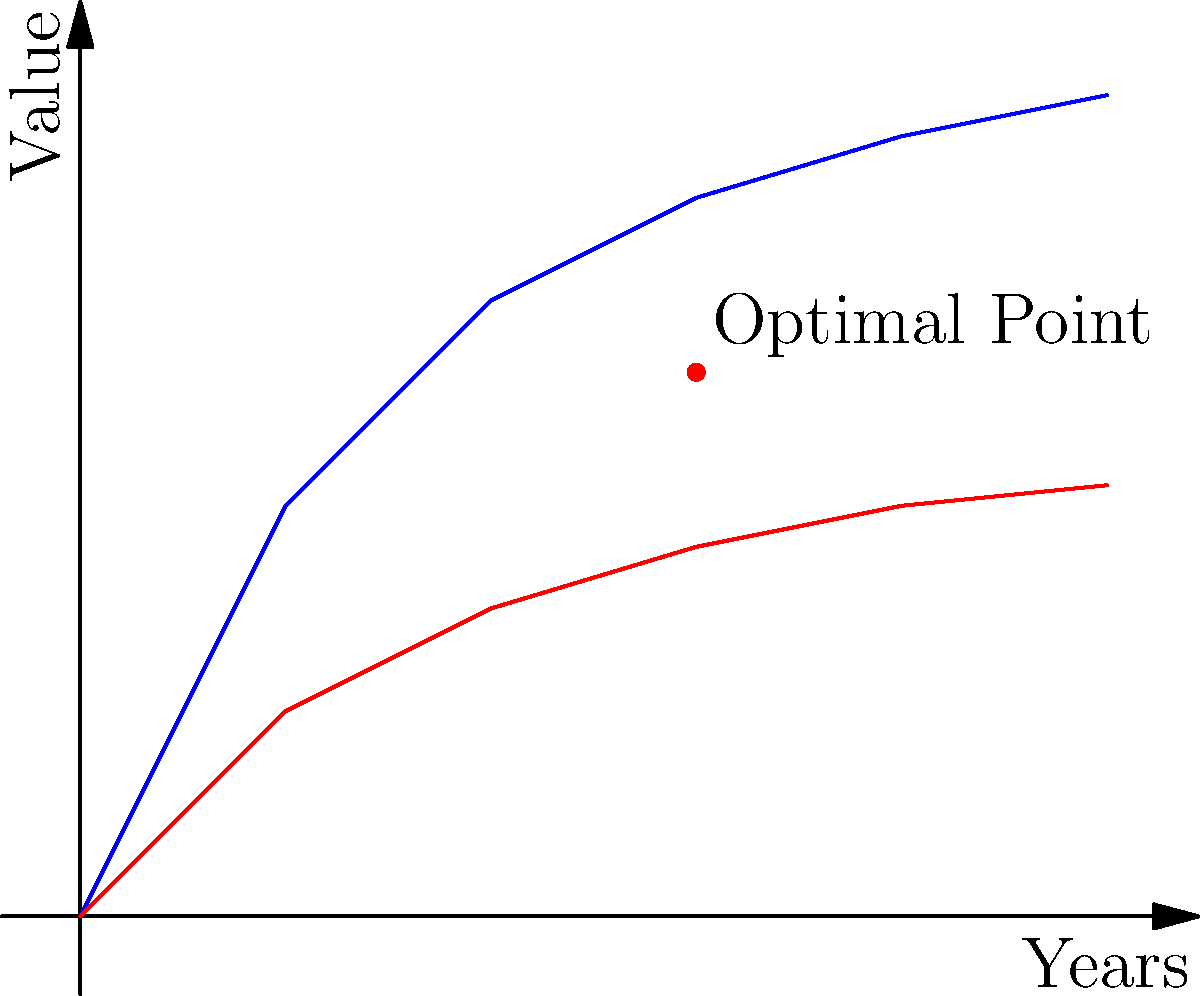Based on the graph showing the relationship between contract duration, early termination fees, and overall value for the business owner, at which point (in years) does the optimal balance between these factors occur? To determine the optimal point, we need to analyze the graph and understand the relationship between the variables:

1. The blue line represents the contract duration, which increases over time but with diminishing returns.
2. The red line represents the early termination fee, which also increases over time but at a slower rate.
3. The optimal point is where the difference between the contract duration value and the early termination fee is maximized, while considering the diminishing returns of longer contracts.

Step-by-step analysis:
1. At year 0, both values start at 0.
2. In years 1-2, there's a rapid increase in contract duration value, outpacing the increase in termination fees.
3. Around year 3, we see the gap between the two lines is at its widest, indicating the maximum benefit for the business owner.
4. After year 3, the rate of increase for contract duration slows significantly, while termination fees continue to rise.
5. The red dot on the graph indicates the optimal point, which occurs at the 3-year mark.

This point represents the best balance between maximizing contract value and minimizing the risk associated with high termination fees.
Answer: 3 years 